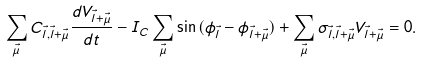<formula> <loc_0><loc_0><loc_500><loc_500>\sum _ { \vec { \mu } } C _ { \vec { l } , \vec { l } + \vec { \mu } } \frac { d V _ { \vec { l } + \vec { \mu } } } { d t } - I _ { C } \sum _ { \vec { \mu } } \sin { ( \phi _ { \vec { l } } - \phi _ { \vec { l } + \vec { \mu } } ) } + \sum _ { \vec { \mu } } \sigma _ { \vec { l } , \vec { l } + \vec { \mu } } V _ { \vec { l } + \vec { \mu } } = 0 .</formula> 